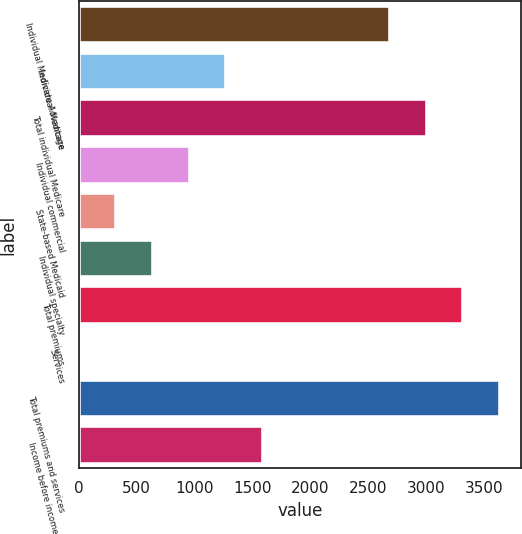Convert chart. <chart><loc_0><loc_0><loc_500><loc_500><bar_chart><fcel>Individual Medicare Advantage<fcel>Individual Medicare<fcel>Total individual Medicare<fcel>Individual commercial<fcel>State-based Medicaid<fcel>Individual specialty<fcel>Total premiums<fcel>Services<fcel>Total premiums and services<fcel>Income before income taxes<nl><fcel>2688<fcel>1276<fcel>3005<fcel>959<fcel>325<fcel>642<fcel>3322<fcel>8<fcel>3639<fcel>1593<nl></chart> 